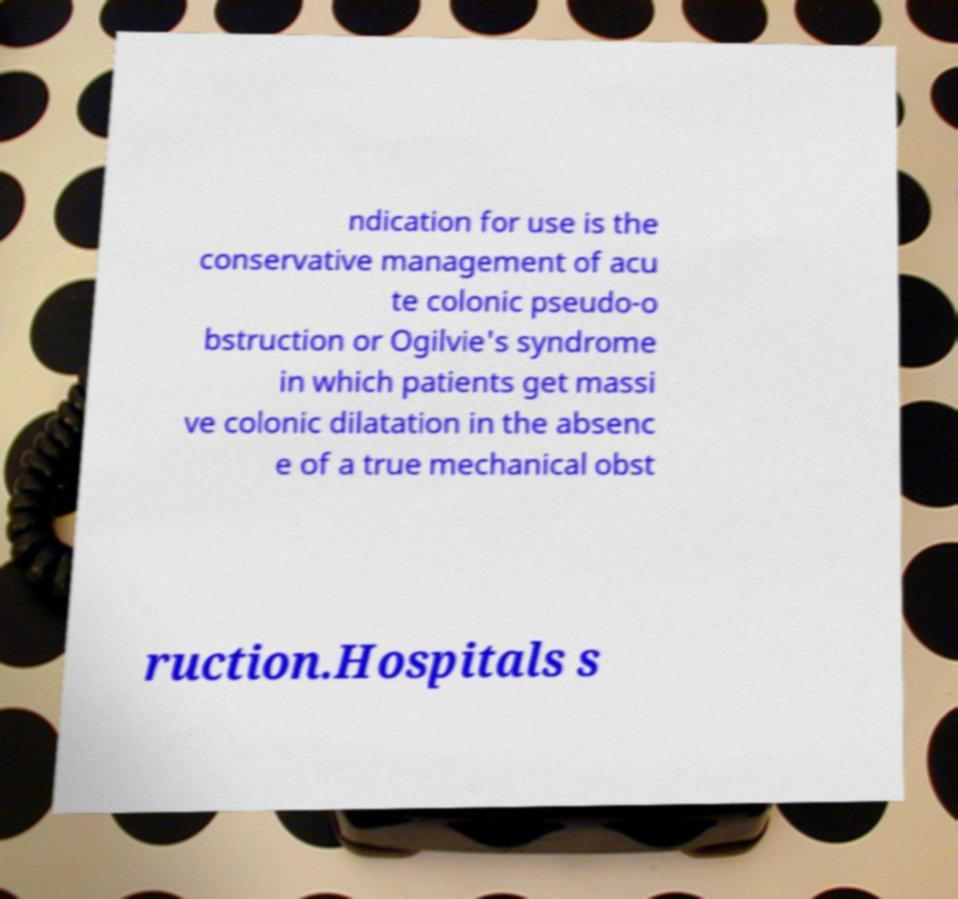Can you read and provide the text displayed in the image?This photo seems to have some interesting text. Can you extract and type it out for me? ndication for use is the conservative management of acu te colonic pseudo-o bstruction or Ogilvie's syndrome in which patients get massi ve colonic dilatation in the absenc e of a true mechanical obst ruction.Hospitals s 